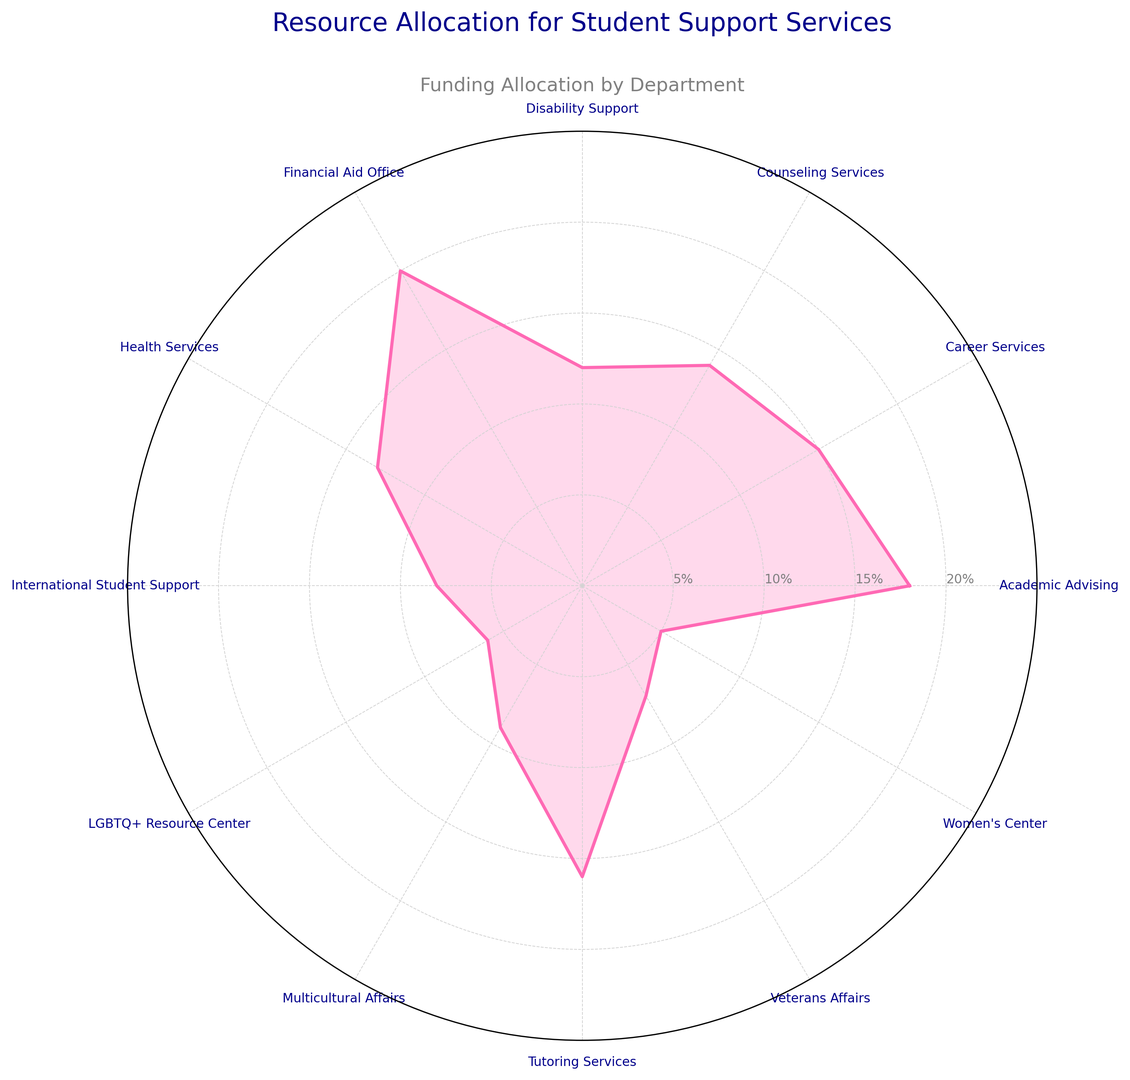How is the funding allocation for Academic Advising compared to Career Services? By looking at the radar chart, we can see that Academic Advising is at a value of 18%, while Career Services is at 15%. Therefore, Academic Advising has a higher funding allocation.
Answer: Academic Advising has more funding than Career Services Which departments receive less funding than Health Services? Health Services is allocated 13% of funding. From the radar chart, we can see that Disability Support (12%), International Student Support (8%), LGBTQ+ Resource Center (6%), Multicultural Affairs (9%), Veterans Affairs (7%), and Women's Center (5%) all receive less funding.
Answer: Disability Support, International Student Support, LGBTQ+ Resource Center, Multicultural Affairs, Veterans Affairs, Women's Center Which department receives the highest allocation? Examining the radar chart shows that Financial Aid Office has the highest allocation at 20%.
Answer: Financial Aid Office What's the difference in funding between the department with the highest allocation and the department with the lowest allocation? The Financial Aid Office has the highest allocation at 20%, and the Women's Center has the lowest at 5%. The difference is 20% - 5% = 15%.
Answer: 15% List the departments receiving over 15% of funding allocation. On the radar chart, the departments above 15% are Academic Advising (18%), Career Services (15% exactly, not over), Financial Aid Office (20%), and Tutoring Services (16%).
Answer: Academic Advising, Financial Aid Office, Tutoring Services How many departments have a funding allocation below 10%? From the radar chart, we identify that the following departments have below 10%: International Student Support (8%), LGBTQ+ Resource Center (6%), Multicultural Affairs (9%), Veterans Affairs (7%), and Women's Center (5%). This results in 5 departments.
Answer: 5 departments What is the combined funding allocation for Health Services and Counseling Services? According to the radar chart, Health Services is allocated 13% and Counseling Services is allocated 14%. The combined allocation is 13% + 14% = 27%.
Answer: 27% Which department's allocation is nearest to the average allocation of all departments? To determine this, first calculate the average funding: (18 + 15 + 14 + 12 + 20 + 13 + 8 + 6 + 9 + 16 + 7 + 5) / 12 = 11.25%. The department allocation closest to 11.25% is Disability Support at 12%.
Answer: Disability Support How does the funding for Tutoring Services compare against the combined funding for LGBTQ+ Resource Center and Women's Center? Tutoring Services is allocated 16%. LGBTQ+ Resource Center is allocated 6% and Women's Center is allocated 5%. Combined, LGBTQ+ Resource Center and Women's Center have 6% + 5% = 11%. Comparing, 16% for Tutoring Services is higher than 11% combined.
Answer: Tutoring Services has more funding 